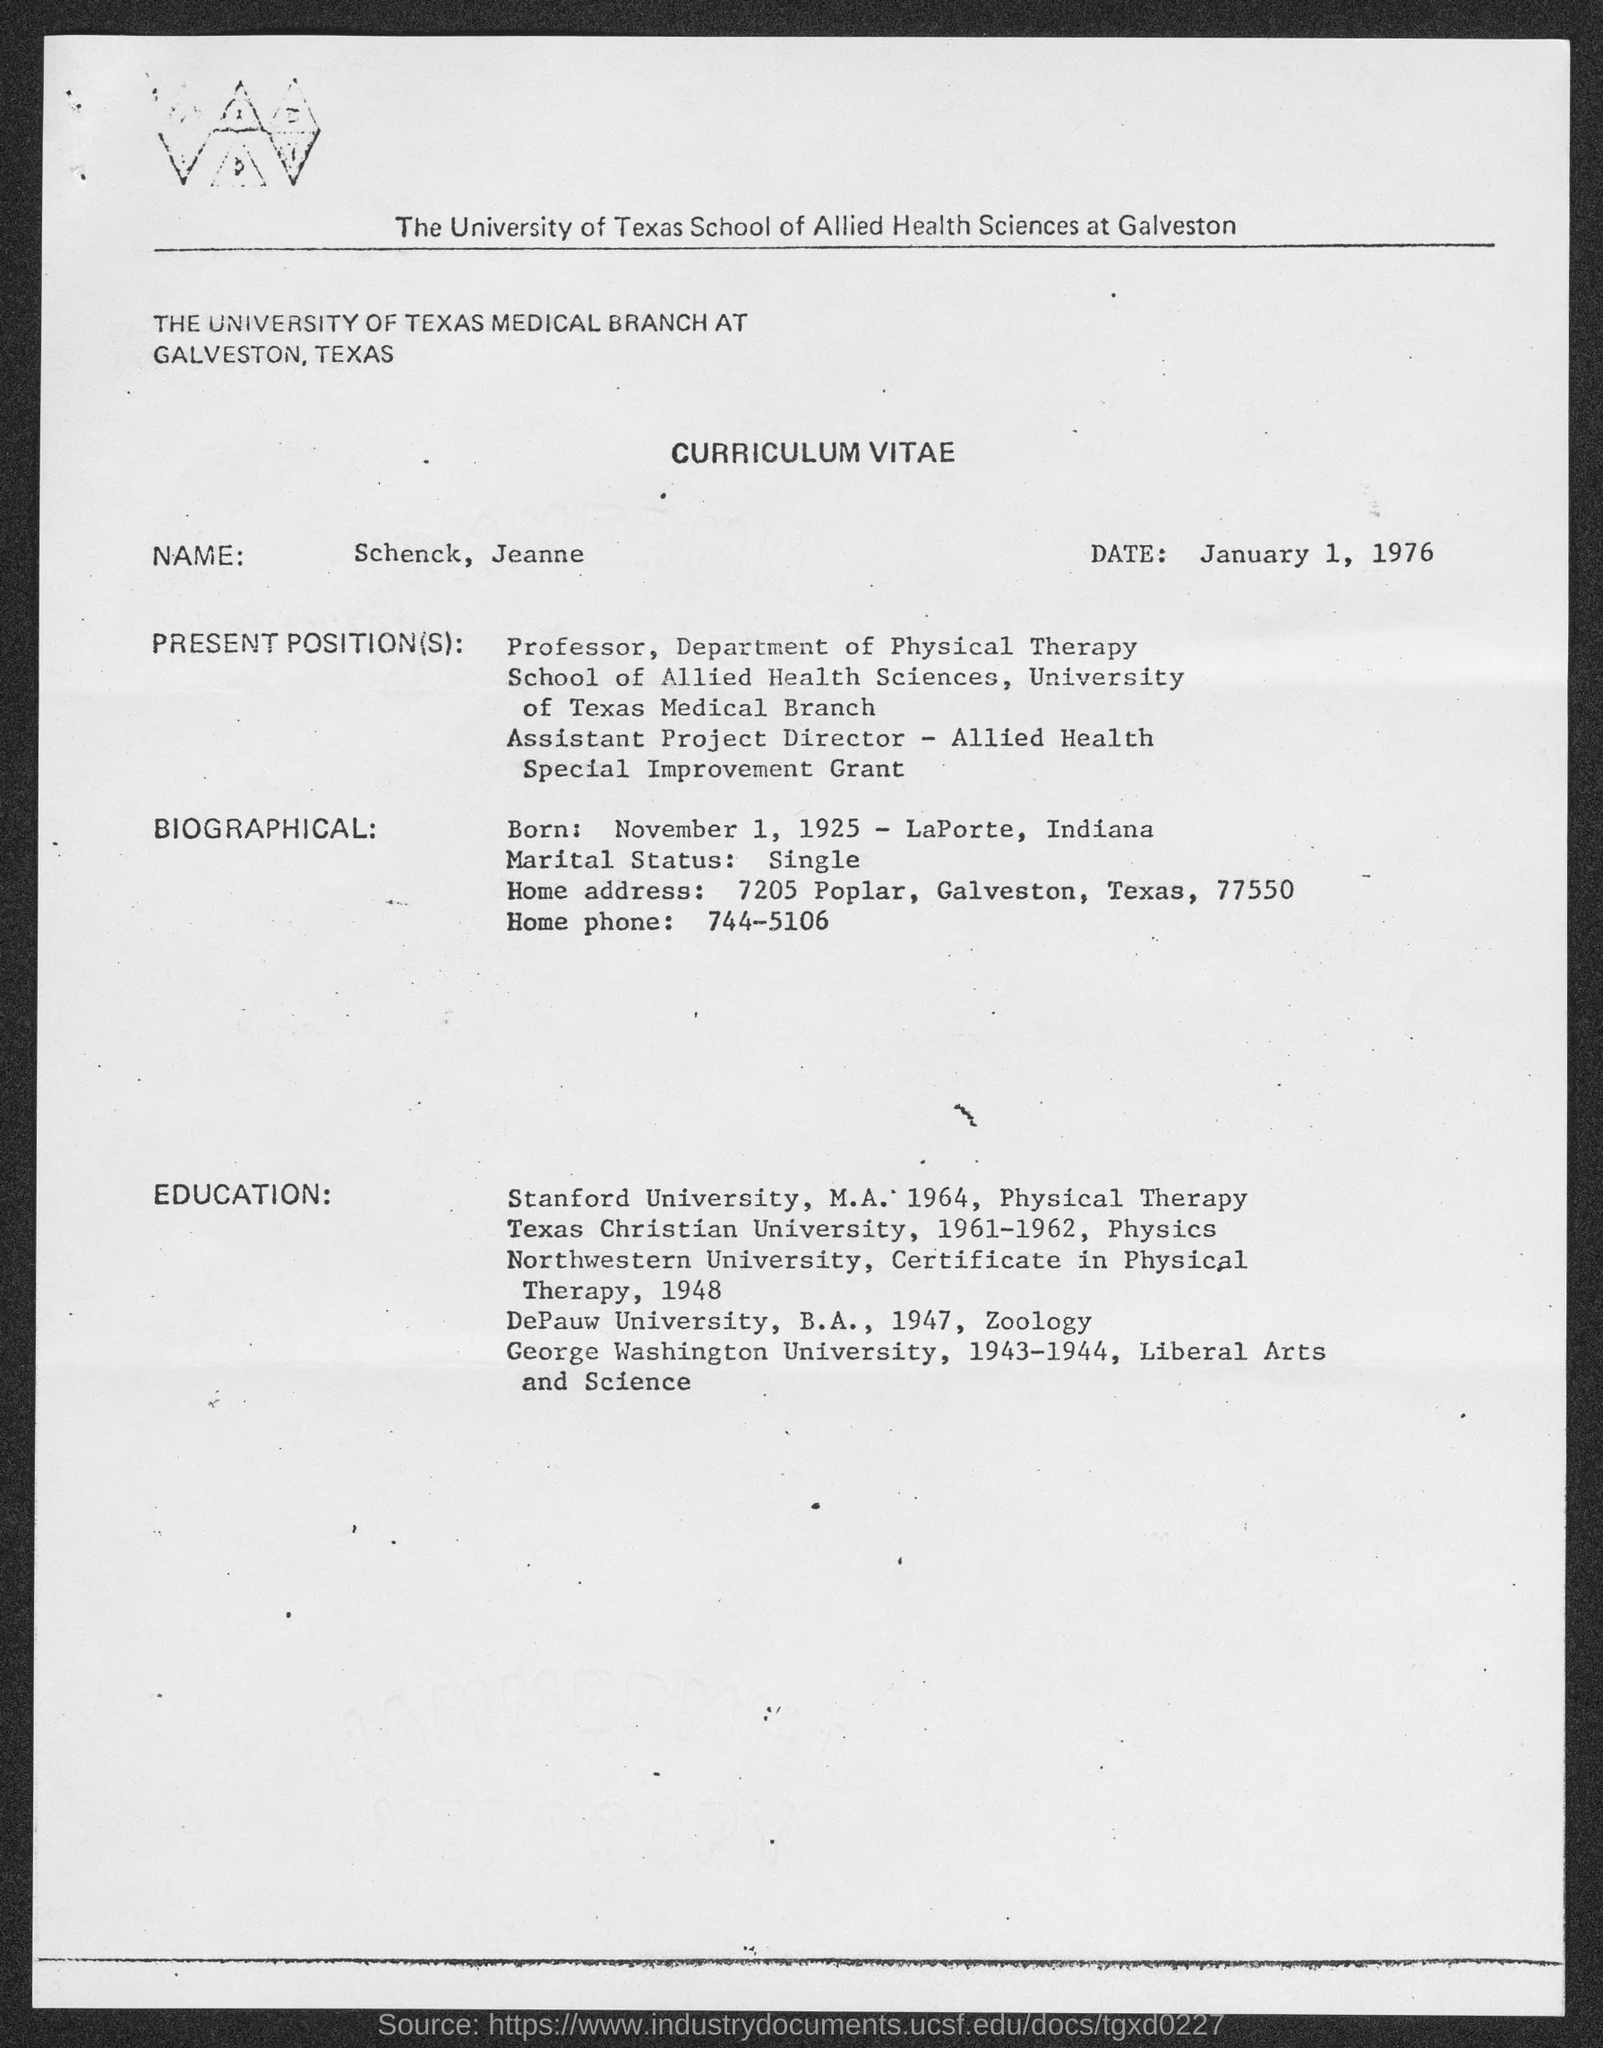Draw attention to some important aspects in this diagram. The home phone number is 744-5106. The date is January 1, 1976. November 1, 1925, is the date of his birth. The name is Schenck, Jeanne Schenck. The home address is 7205 Poplar, Galveston, Texas, 77550. 